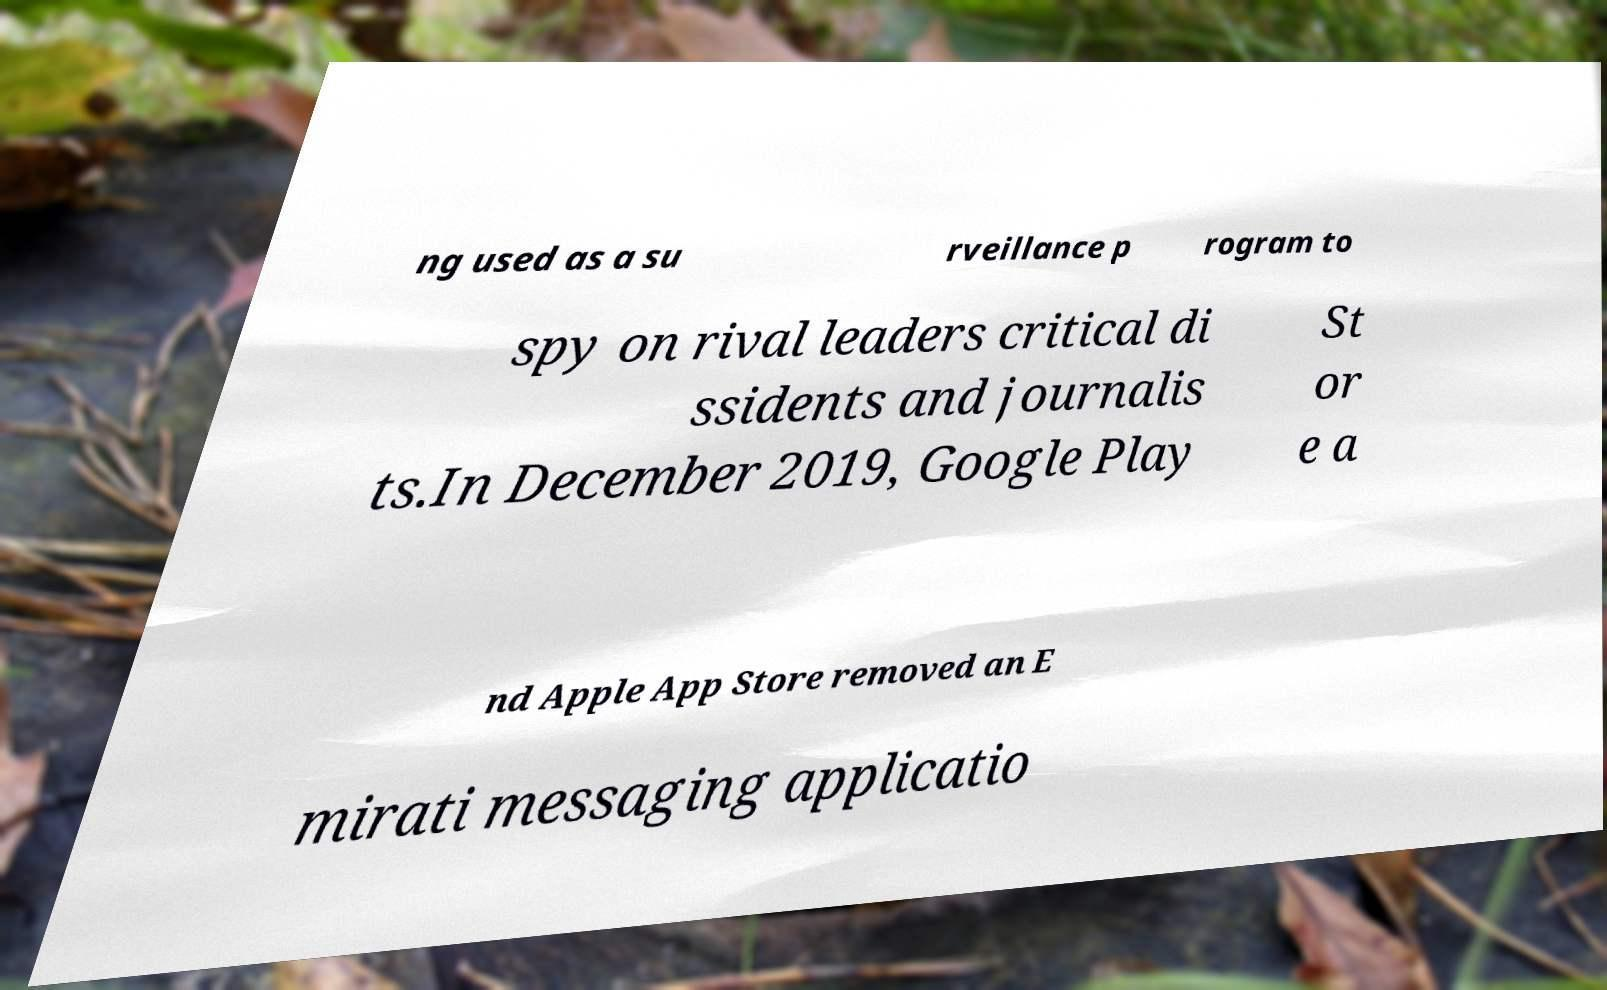Could you extract and type out the text from this image? ng used as a su rveillance p rogram to spy on rival leaders critical di ssidents and journalis ts.In December 2019, Google Play St or e a nd Apple App Store removed an E mirati messaging applicatio 